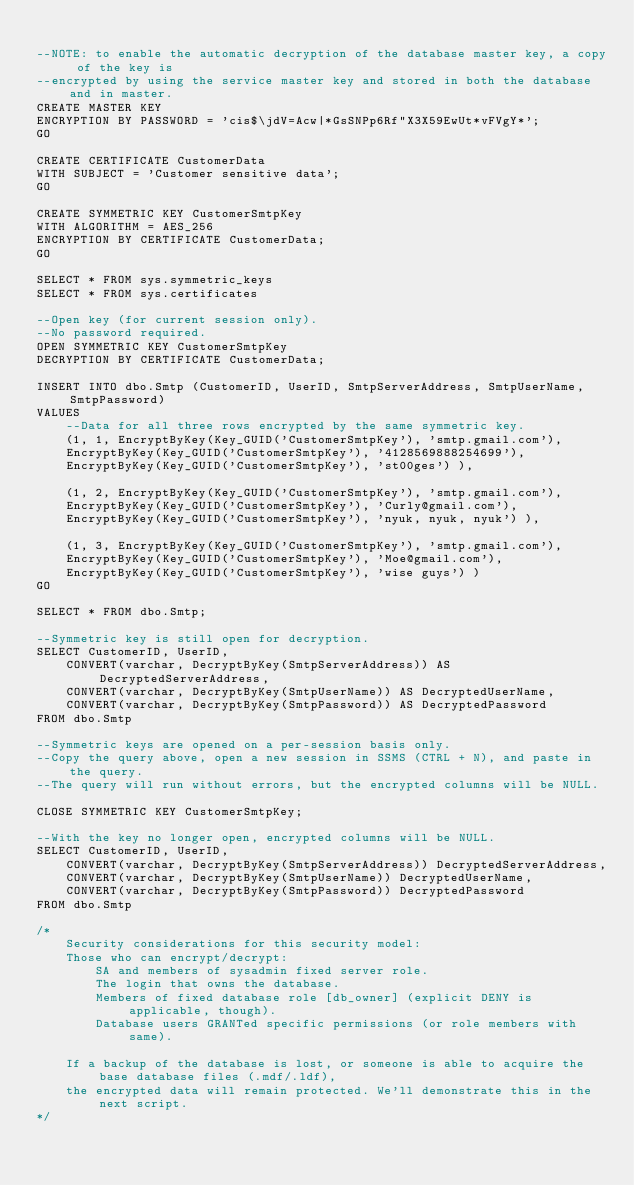<code> <loc_0><loc_0><loc_500><loc_500><_SQL_>
--NOTE: to enable the automatic decryption of the database master key, a copy of the key is 
--encrypted by using the service master key and stored in both the database and in master.
CREATE MASTER KEY 
ENCRYPTION BY PASSWORD = 'cis$\jdV=Acw|*GsSNPp6Rf"X3X59EwUt*vFVgY*';
GO

CREATE CERTIFICATE CustomerData
WITH SUBJECT = 'Customer sensitive data';
GO

CREATE SYMMETRIC KEY CustomerSmtpKey  
WITH ALGORITHM = AES_256  
ENCRYPTION BY CERTIFICATE CustomerData;  
GO 

SELECT * FROM sys.symmetric_keys
SELECT * FROM sys.certificates

--Open key (for current session only).
--No password required.
OPEN SYMMETRIC KEY CustomerSmtpKey  
DECRYPTION BY CERTIFICATE CustomerData; 

INSERT INTO dbo.Smtp (CustomerID, UserID, SmtpServerAddress, SmtpUserName, SmtpPassword)
VALUES 
	--Data for all three rows encrypted by the same symmetric key.
	(1, 1, EncryptByKey(Key_GUID('CustomerSmtpKey'), 'smtp.gmail.com'),
	EncryptByKey(Key_GUID('CustomerSmtpKey'), '4128569888254699'),
	EncryptByKey(Key_GUID('CustomerSmtpKey'), 'st00ges') ),

	(1, 2, EncryptByKey(Key_GUID('CustomerSmtpKey'), 'smtp.gmail.com'),
	EncryptByKey(Key_GUID('CustomerSmtpKey'), 'Curly@gmail.com'),
	EncryptByKey(Key_GUID('CustomerSmtpKey'), 'nyuk, nyuk, nyuk') ),

	(1, 3, EncryptByKey(Key_GUID('CustomerSmtpKey'), 'smtp.gmail.com'),
	EncryptByKey(Key_GUID('CustomerSmtpKey'), 'Moe@gmail.com'),
	EncryptByKey(Key_GUID('CustomerSmtpKey'), 'wise guys') )
GO

SELECT * FROM dbo.Smtp;

--Symmetric key is still open for decryption.
SELECT CustomerID, UserID, 
	CONVERT(varchar, DecryptByKey(SmtpServerAddress)) AS DecryptedServerAddress,
	CONVERT(varchar, DecryptByKey(SmtpUserName)) AS DecryptedUserName,
	CONVERT(varchar, DecryptByKey(SmtpPassword)) AS DecryptedPassword
FROM dbo.Smtp 

--Symmetric keys are opened on a per-session basis only.
--Copy the query above, open a new session in SSMS (CTRL + N), and paste in the query.
--The query will run without errors, but the encrypted columns will be NULL.

CLOSE SYMMETRIC KEY CustomerSmtpKey;

--With the key no longer open, encrypted columns will be NULL.
SELECT CustomerID, UserID, 
	CONVERT(varchar, DecryptByKey(SmtpServerAddress)) DecryptedServerAddress,
	CONVERT(varchar, DecryptByKey(SmtpUserName)) DecryptedUserName,
	CONVERT(varchar, DecryptByKey(SmtpPassword)) DecryptedPassword
FROM dbo.Smtp 

/*
	Security considerations for this security model:
	Those who can encrypt/decrypt:
		SA and members of sysadmin fixed server role.
		The login that owns the database.
		Members of fixed database role [db_owner] (explicit DENY is applicable, though).
		Database users GRANTed specific permissions (or role members with same).

	If a backup of the database is lost, or someone is able to acquire the base database files (.mdf/.ldf),
	the encrypted data will remain protected. We'll demonstrate this in the next script.
*/
</code> 